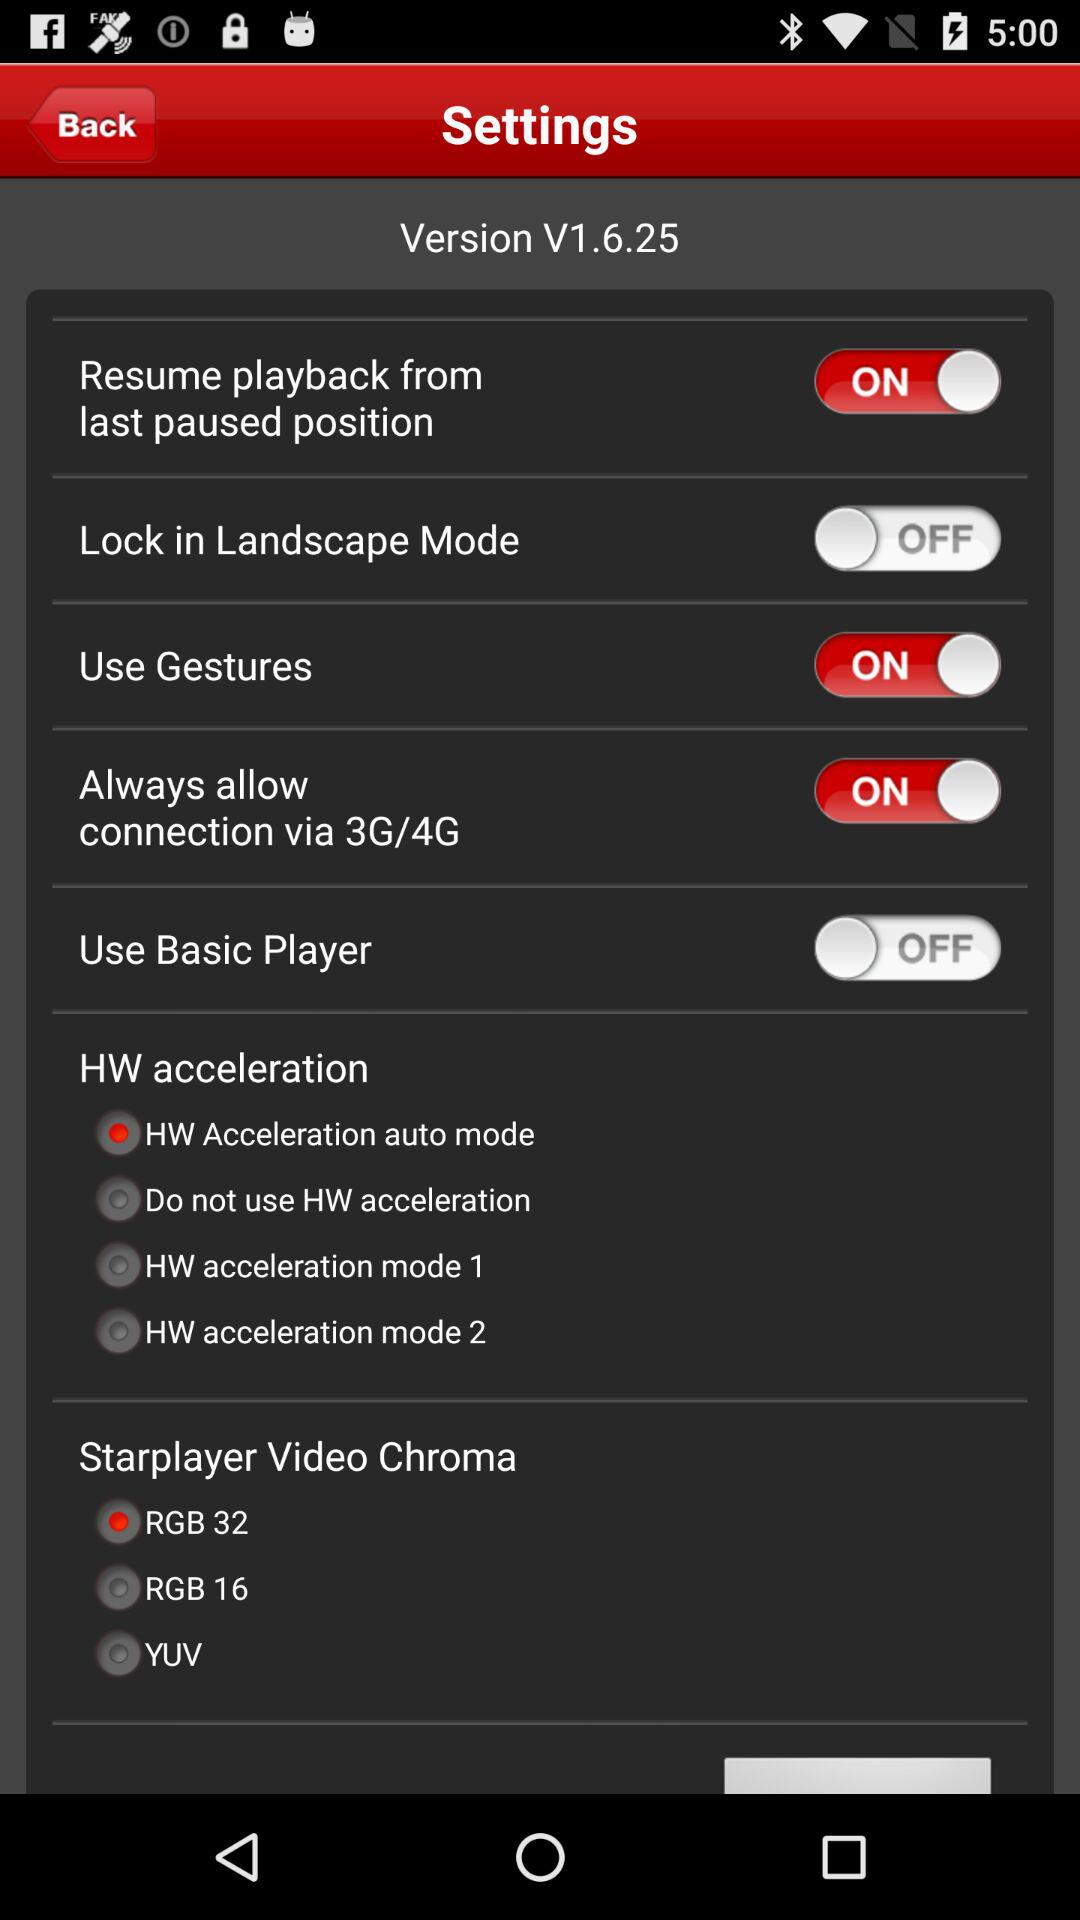What is the version? The version is V1.6.25. 